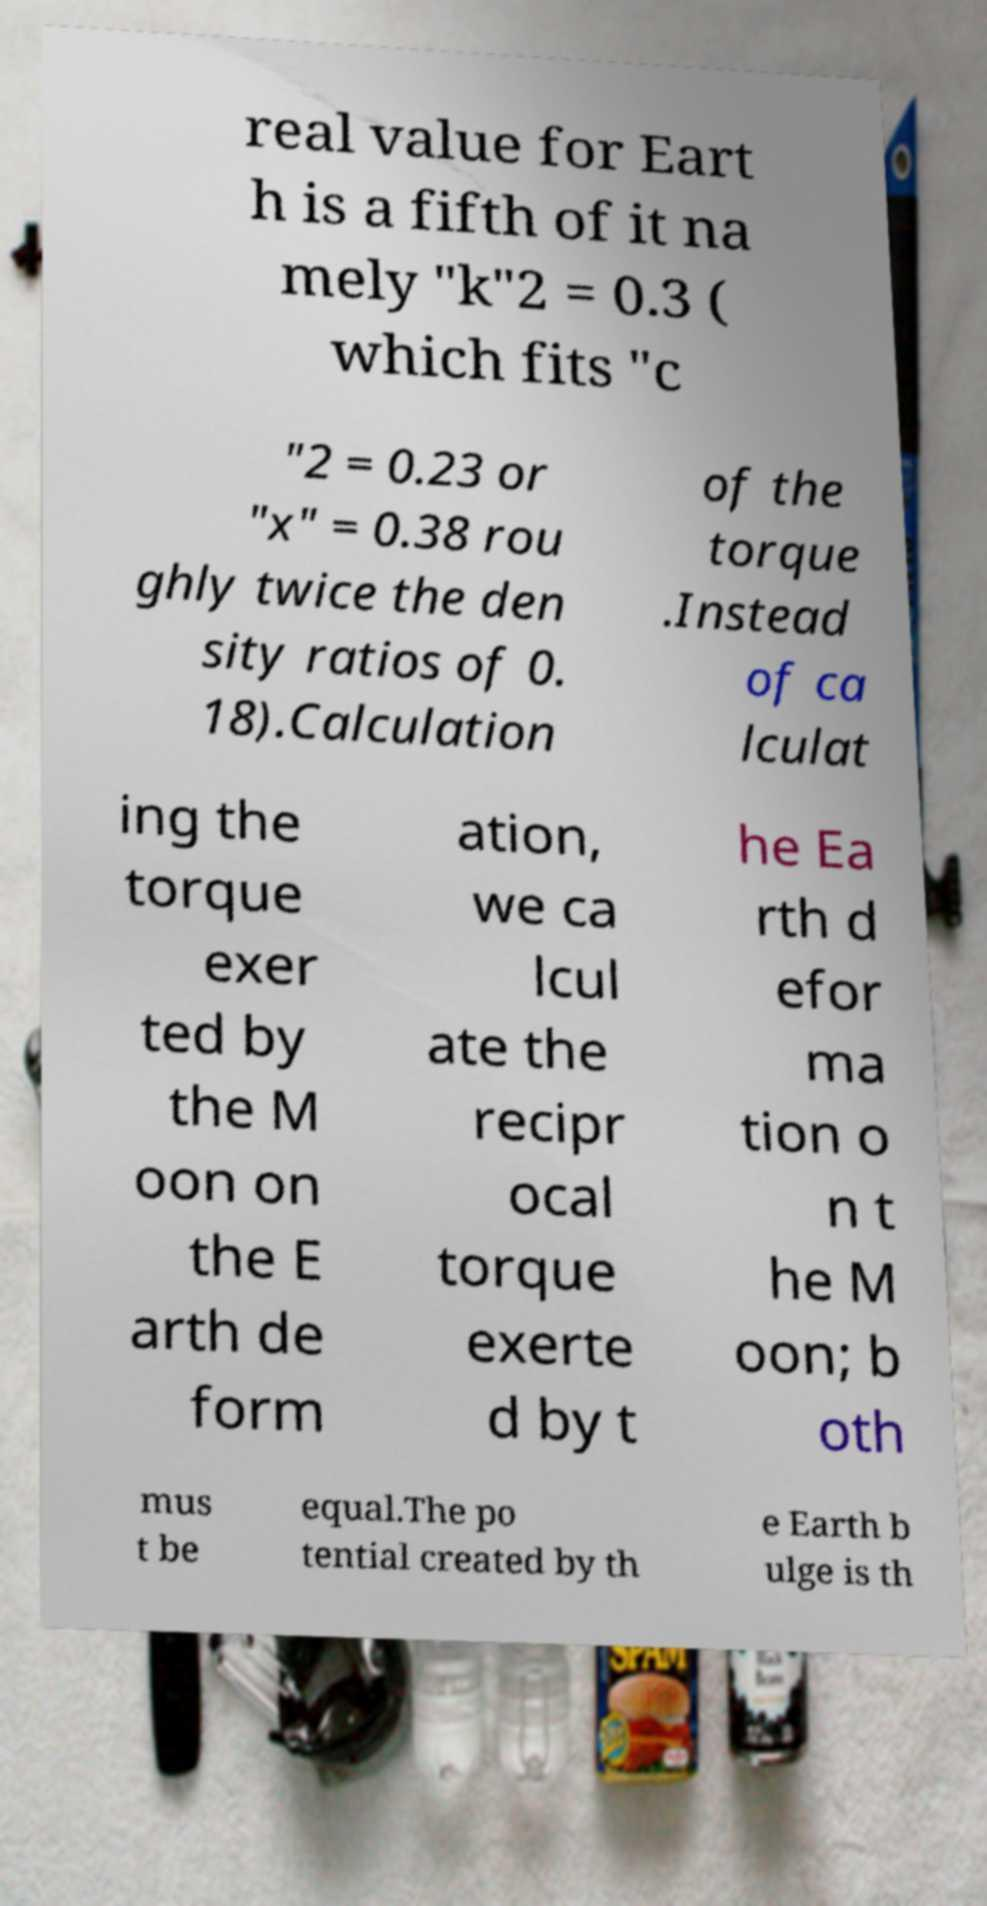Can you read and provide the text displayed in the image?This photo seems to have some interesting text. Can you extract and type it out for me? real value for Eart h is a fifth of it na mely "k"2 = 0.3 ( which fits "c "2 = 0.23 or "x" = 0.38 rou ghly twice the den sity ratios of 0. 18).Calculation of the torque .Instead of ca lculat ing the torque exer ted by the M oon on the E arth de form ation, we ca lcul ate the recipr ocal torque exerte d by t he Ea rth d efor ma tion o n t he M oon; b oth mus t be equal.The po tential created by th e Earth b ulge is th 